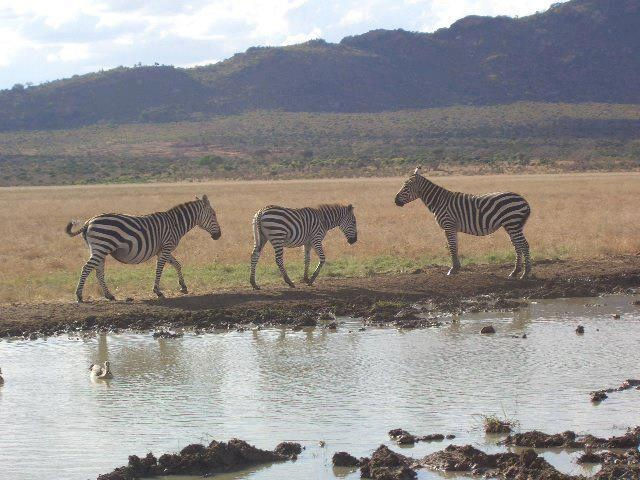Describe the objects in this image and their specific colors. I can see zebra in white, gray, and black tones, zebra in white, gray, and black tones, and zebra in white, gray, and black tones in this image. 